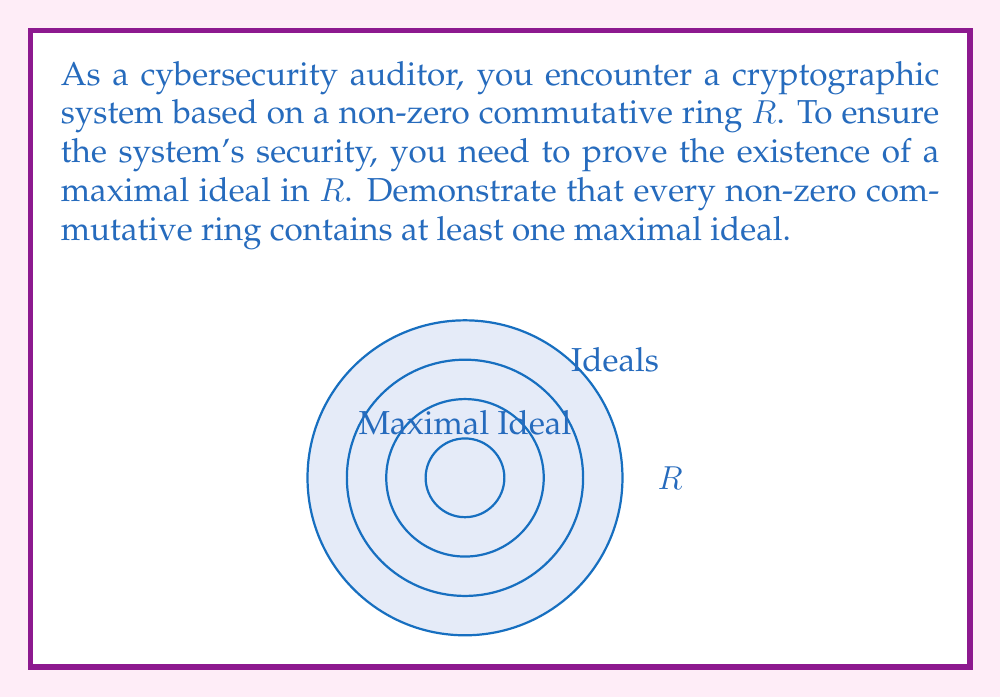Can you answer this question? To prove the existence of a maximal ideal in a non-zero commutative ring $R$, we can follow these steps:

1) Let $S$ be the set of all proper ideals of $R$. Note that $S$ is non-empty because $(0)$ is always a proper ideal of $R$ (since $R$ is non-zero).

2) Define a partial order $\subseteq$ on $S$ based on set inclusion.

3) Let $C$ be any chain in $S$, i.e., a totally ordered subset of $S$.

4) Define $I = \bigcup_{J \in C} J$, the union of all ideals in the chain $C$.

5) We can prove that $I$ is an ideal of $R$:
   - For $a,b \in I$, $\exists J_1, J_2 \in C$ such that $a \in J_1$, $b \in J_2$.
   - Since $C$ is totally ordered, either $J_1 \subseteq J_2$ or $J_2 \subseteq J_1$.
   - Let's say $J_1 \subseteq J_2$. Then $a,b \in J_2$, so $a+b \in J_2 \subseteq I$.
   - For $r \in R$ and $a \in I$, $\exists J \in C$ such that $a \in J$, so $ra \in J \subseteq I$.

6) $I$ is an upper bound for $C$ in $S$, as $J \subseteq I$ for all $J \in C$.

7) By Zorn's Lemma, $S$ has a maximal element $M$.

8) This maximal element $M$ is a maximal ideal of $R$:
   - $M$ is an ideal of $R$ (as it's in $S$).
   - If $I$ is an ideal of $R$ with $M \subsetneq I \subseteq R$, then $I = R$ (otherwise $M$ wouldn't be maximal in $S$).

Therefore, we have proved the existence of a maximal ideal in $R$.
Answer: Every non-zero commutative ring contains a maximal ideal by Zorn's Lemma. 